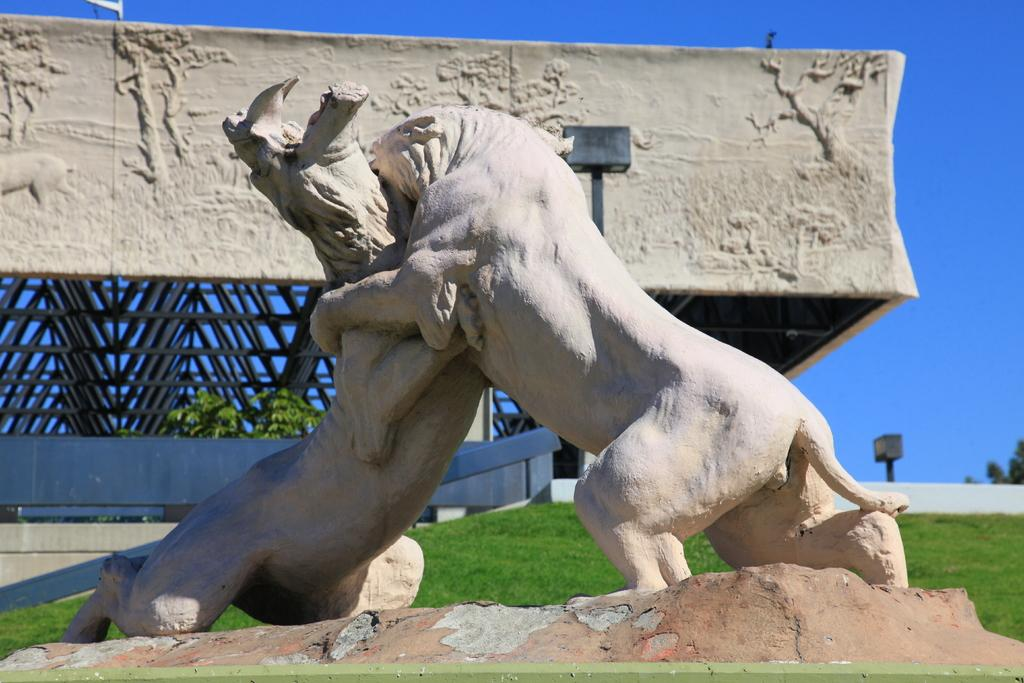What type of artwork can be seen in the image? There are sculptures in the image. What type of natural environment is present in the image? There is grass and plants in the image. What type of structure is visible in the image? There is a wall in the image. What can be seen in the background of the image? The sky is visible in the background of the image. What type of food is being cooked on the stove in the image? There is no stove or food present in the image; it features sculptures, grass, plants, a wall, and the sky. What type of flowers are blooming in the image? There is no mention of flowers in the image; it features sculptures, grass, plants, a wall, and the sky. 